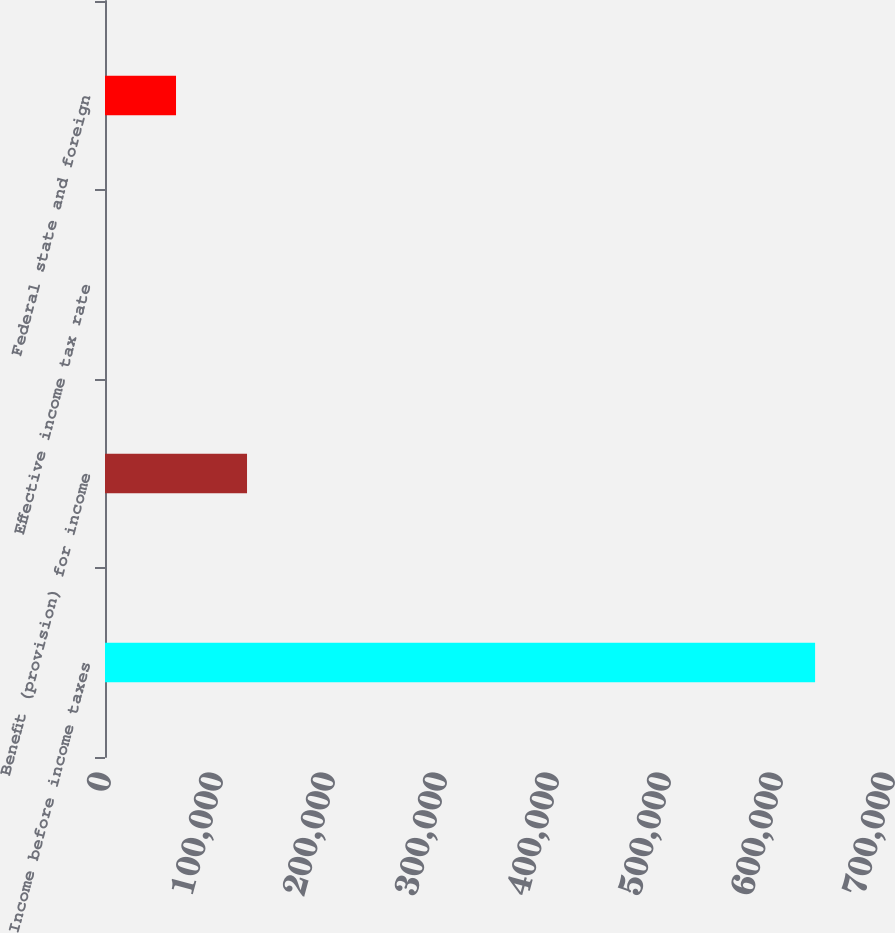Convert chart. <chart><loc_0><loc_0><loc_500><loc_500><bar_chart><fcel>Income before income taxes<fcel>Benefit (provision) for income<fcel>Effective income tax rate<fcel>Federal state and foreign<nl><fcel>634006<fcel>126808<fcel>7.9<fcel>63407.7<nl></chart> 